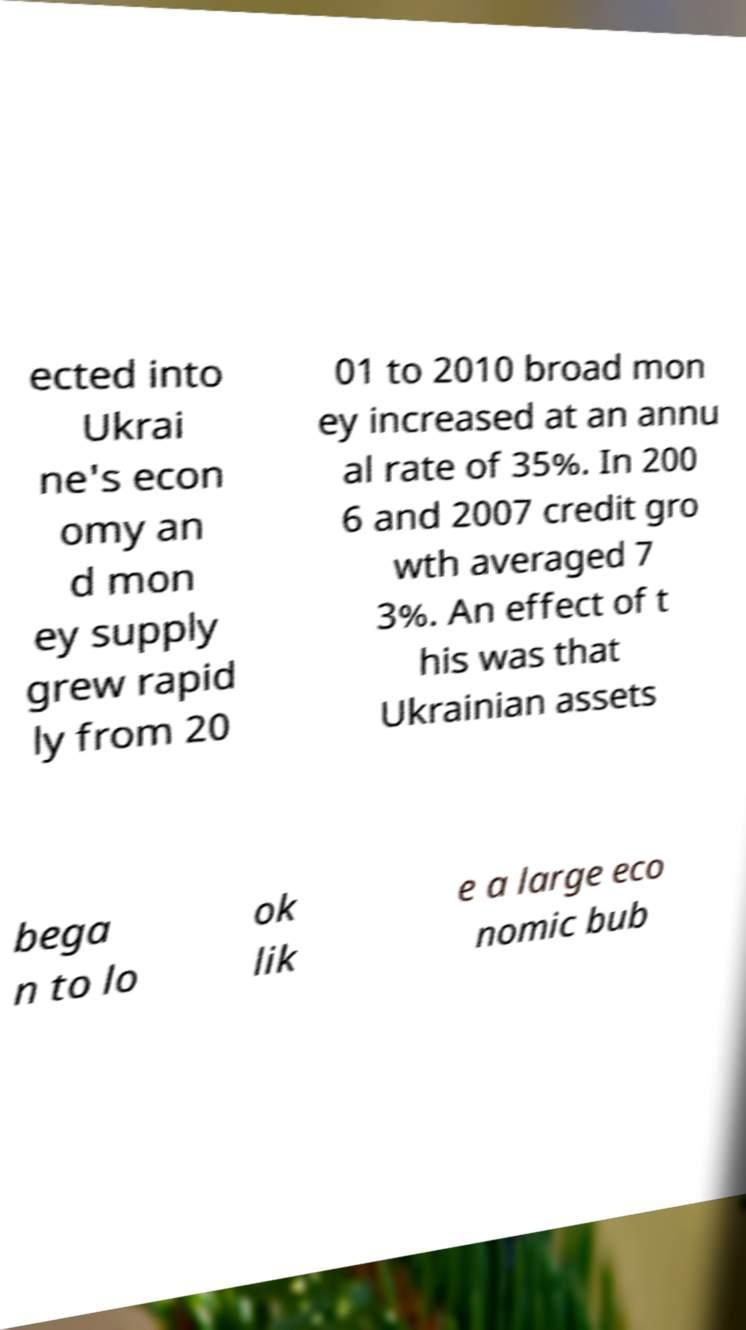Please read and relay the text visible in this image. What does it say? ected into Ukrai ne's econ omy an d mon ey supply grew rapid ly from 20 01 to 2010 broad mon ey increased at an annu al rate of 35%. In 200 6 and 2007 credit gro wth averaged 7 3%. An effect of t his was that Ukrainian assets bega n to lo ok lik e a large eco nomic bub 